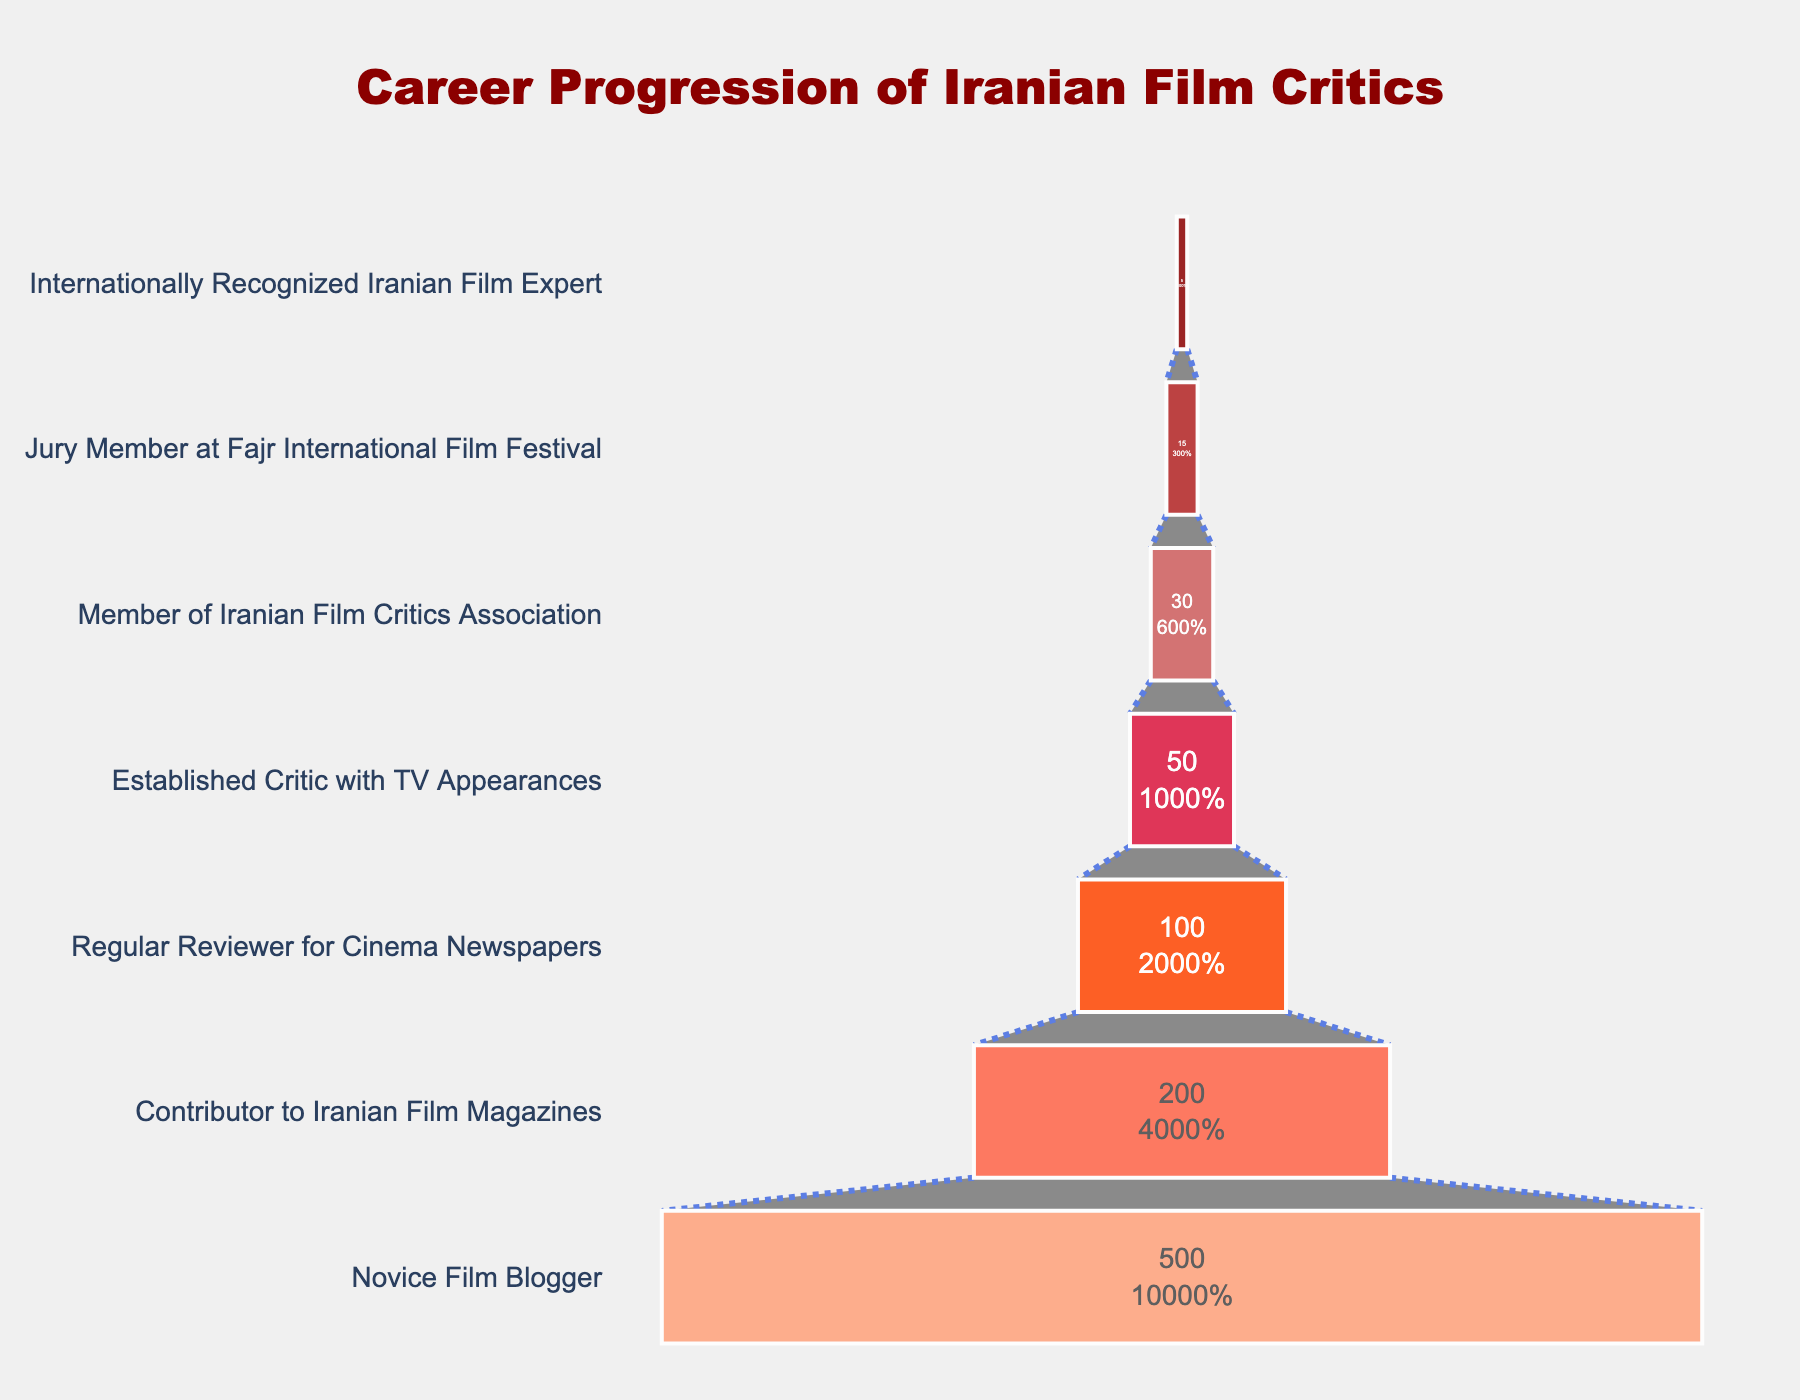What is the title of the chart? The title is typically located at the top center of the figure. In this case, it reads: "Career Progression of Iranian Film Critics".
Answer: Career Progression of Iranian Film Critics How many stages are there in the career progression of Iranian film critics? By counting the y-axis labels in the funnel chart, we can determine the total number of stages. There are 7 stages shown.
Answer: 7 Which stage has the highest number of critics? The size of the sections in a funnel chart indicates the quantity. The largest section is at the top, labelled "Novice Film Blogger" with 500 critics.
Answer: Novice Film Blogger Between which two stages does the largest drop in the number of critics occur? To find this, we need to compare the differences in the number of critics between adjacent stages. The largest drop is between "Novice Film Blogger" (500) and "Contributor to Iranian Film Magazines" (200), a decline of 300 critics.
Answer: Novice Film Blogger and Contributor to Iranian Film Magazines What percentage of the total number of critics are veteran critics who are Members of the Iranian Film Critics Association? First, find the total number of critics, which is the sum of all stages: 900. The number of "Members of Iranian Film Critics Association" is 30. The percentage is calculated as (30/900) * 100%.
Answer: 3.33% Comparing the stages of "Regular Reviewer for Cinema Newspapers" and "Jury Member at Fajr International Film Festival," which stage has more critics and by how many? "Regular Reviewer for Cinema Newspapers" has 100 critics and "Jury Member at Fajr International Film Festival" has 15. The difference is 100 - 15 = 85 critics.
Answer: Regular Reviewer for Cinema Newspapers by 85 What is the percentage loss of critics from "Established Critic with TV Appearances" to "Jury Member at Fajr International Film Festival"? The number of critics drops from 50 to 15 between these stages. The percentage loss is calculated as ((50 - 15) / 50) * 100%.
Answer: 70% How many critics in total progress to at least the "Established Critic with TV Appearances" stage? Sum the number of critics from "Established Critic with TV Appearances" and all stages below it: 50 + 30 + 15 + 5.
Answer: 100 How much more common is it to be a "Contributor to Iranian Film Magazines" than an "Internationally Recognized Iranian Film Expert"? The number of "Contributors to Iranian Film Magazines" is 200, and "Internationally Recognized Iranian Film Experts" is 5. The ratio is 200 / 5.
Answer: 40 times more common At what stage is the quote from Mohammad Reza Jalilvand located in the chart? The quote is given as an annotation below the funnel chart, not directly tied to any specific stage. It appears below the final stage.
Answer: Below the funnel chart 